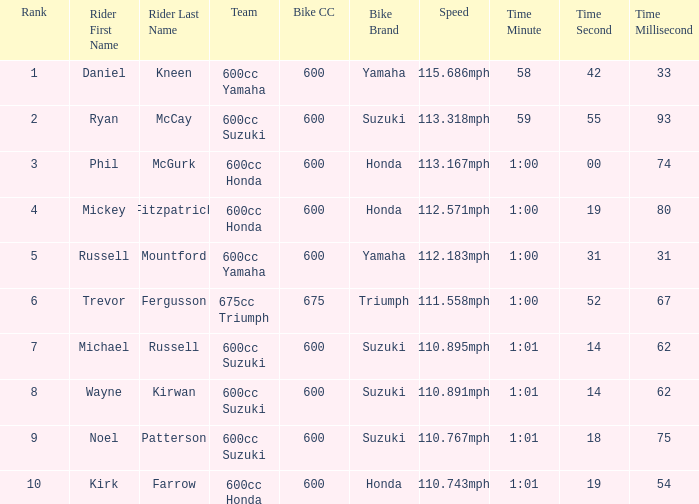How many ranks have michael russell as the rider? 7.0. 